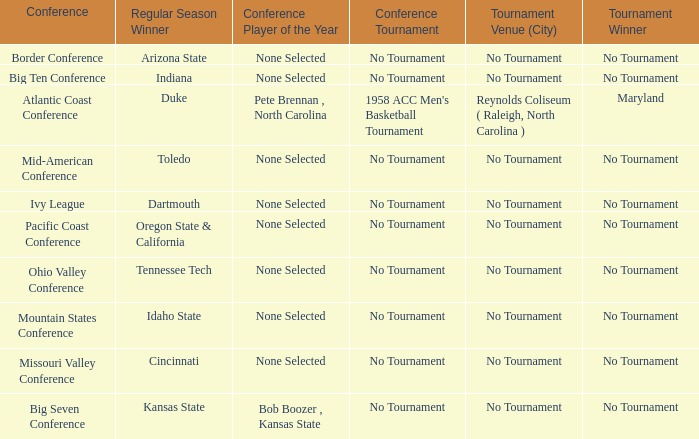Who won the regular season when Maryland won the tournament? Duke. 